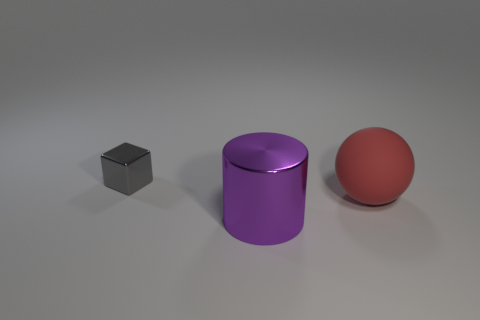Add 3 yellow metallic cylinders. How many objects exist? 6 Subtract all balls. How many objects are left? 2 Subtract all small metallic cubes. Subtract all purple shiny cylinders. How many objects are left? 1 Add 1 tiny things. How many tiny things are left? 2 Add 3 small blue cylinders. How many small blue cylinders exist? 3 Subtract 0 yellow cylinders. How many objects are left? 3 